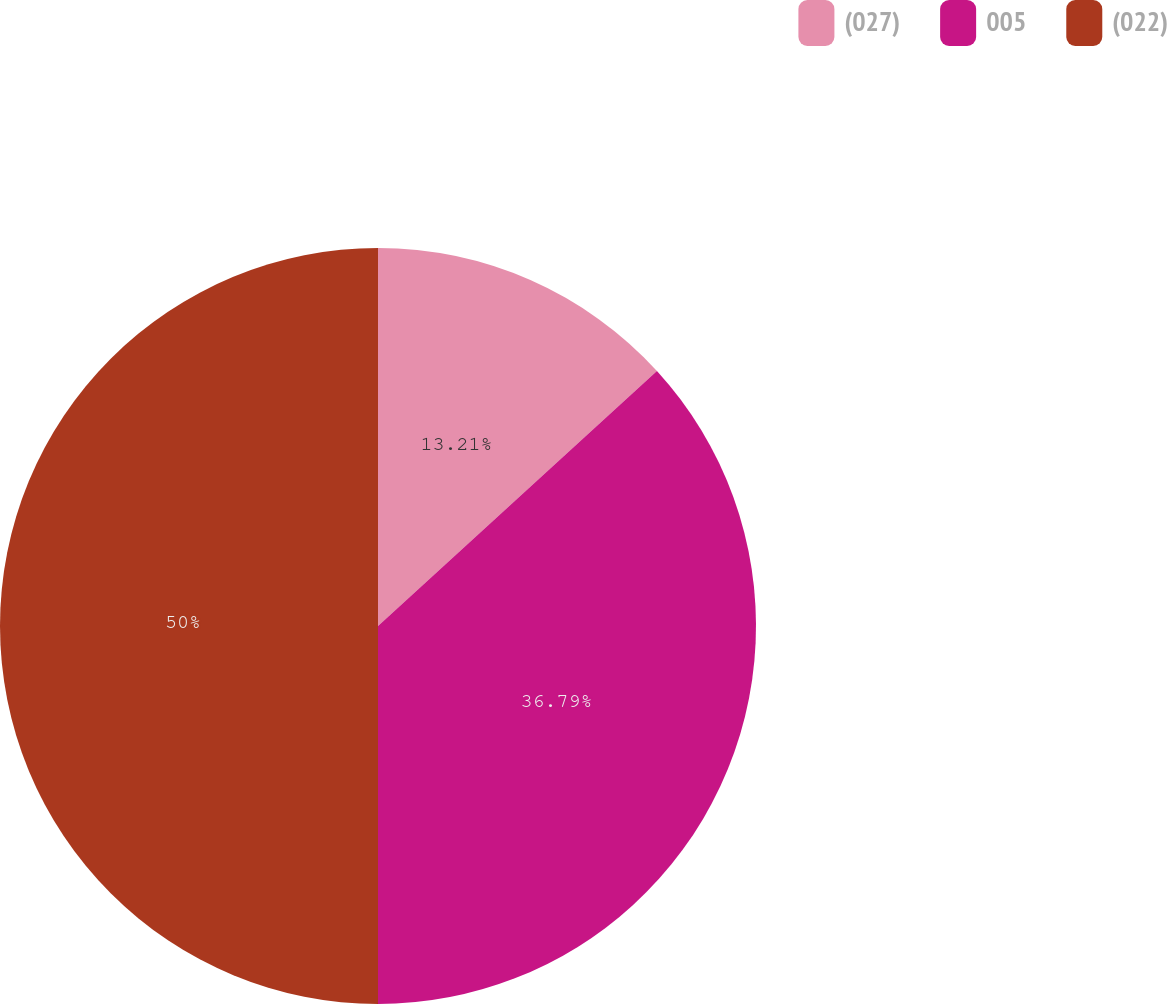<chart> <loc_0><loc_0><loc_500><loc_500><pie_chart><fcel>(027)<fcel>005<fcel>(022)<nl><fcel>13.21%<fcel>36.79%<fcel>50.0%<nl></chart> 